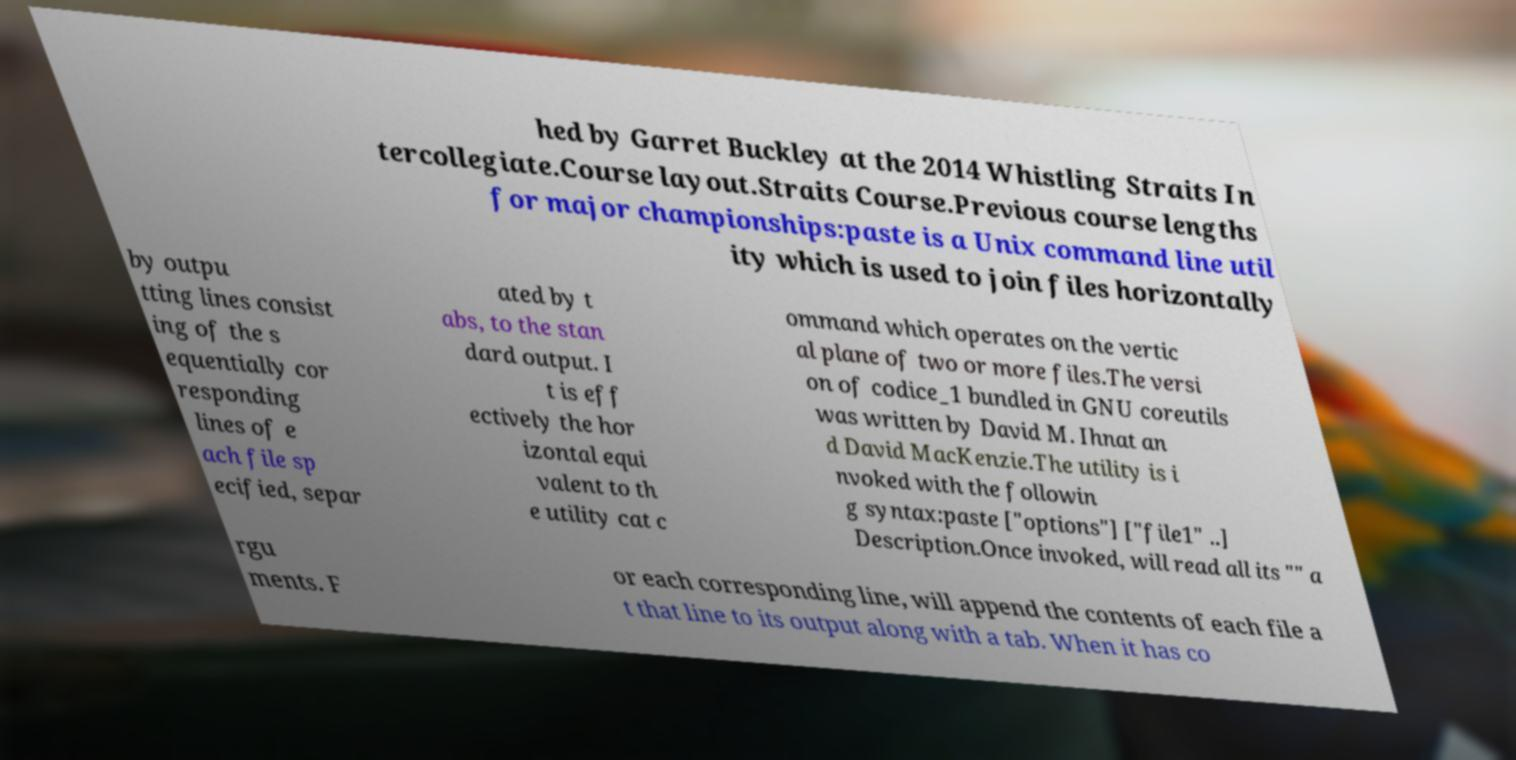Please read and relay the text visible in this image. What does it say? hed by Garret Buckley at the 2014 Whistling Straits In tercollegiate.Course layout.Straits Course.Previous course lengths for major championships:paste is a Unix command line util ity which is used to join files horizontally by outpu tting lines consist ing of the s equentially cor responding lines of e ach file sp ecified, separ ated by t abs, to the stan dard output. I t is eff ectively the hor izontal equi valent to th e utility cat c ommand which operates on the vertic al plane of two or more files.The versi on of codice_1 bundled in GNU coreutils was written by David M. Ihnat an d David MacKenzie.The utility is i nvoked with the followin g syntax:paste ["options"] ["file1" ..] Description.Once invoked, will read all its "" a rgu ments. F or each corresponding line, will append the contents of each file a t that line to its output along with a tab. When it has co 